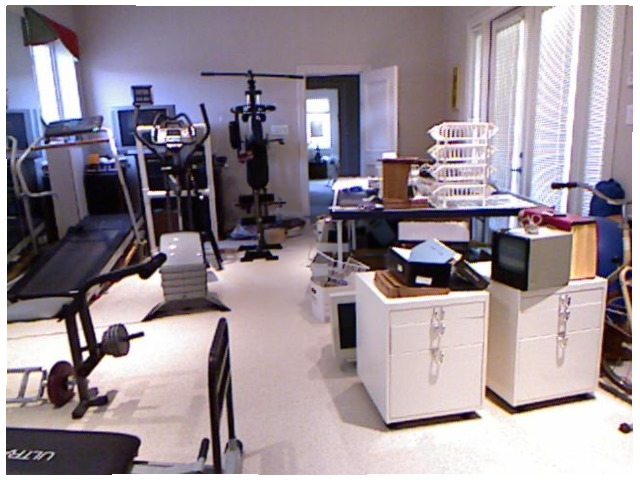<image>
Is the gym set in front of the table? No. The gym set is not in front of the table. The spatial positioning shows a different relationship between these objects. 